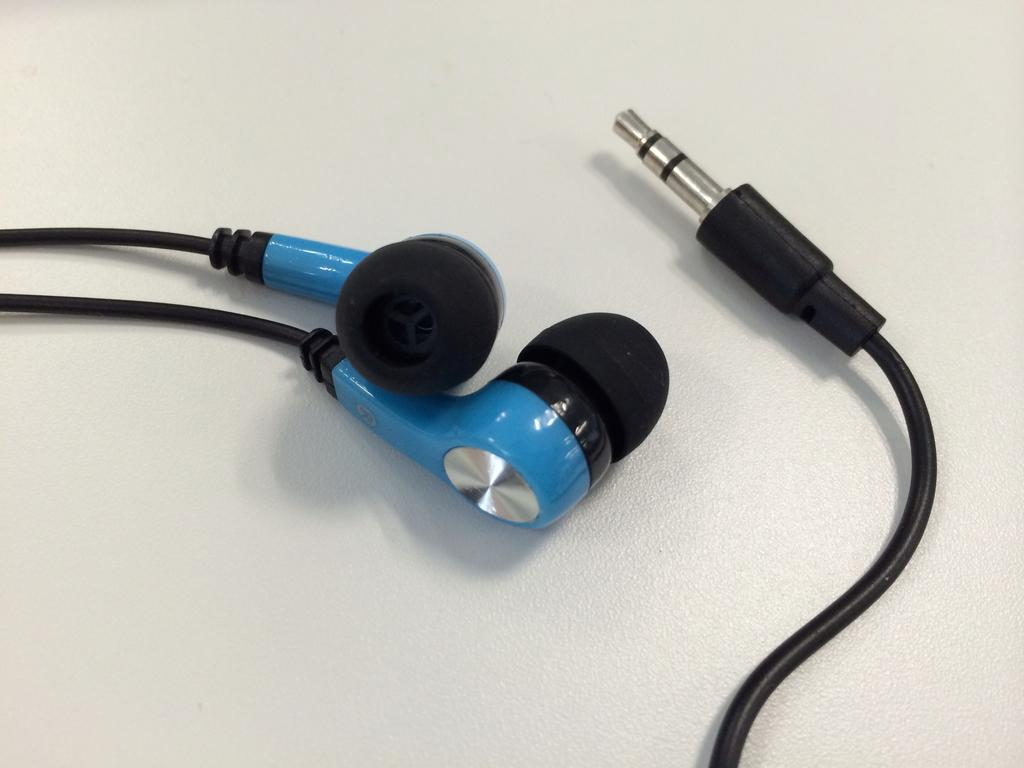What is the main object in the image? There are headphones in the image. What color is the surface on which the headphones are placed? The headphones are on a white colored surface. How many bones can be seen in the image? There are no bones present in the image; it only features headphones on a white surface. 